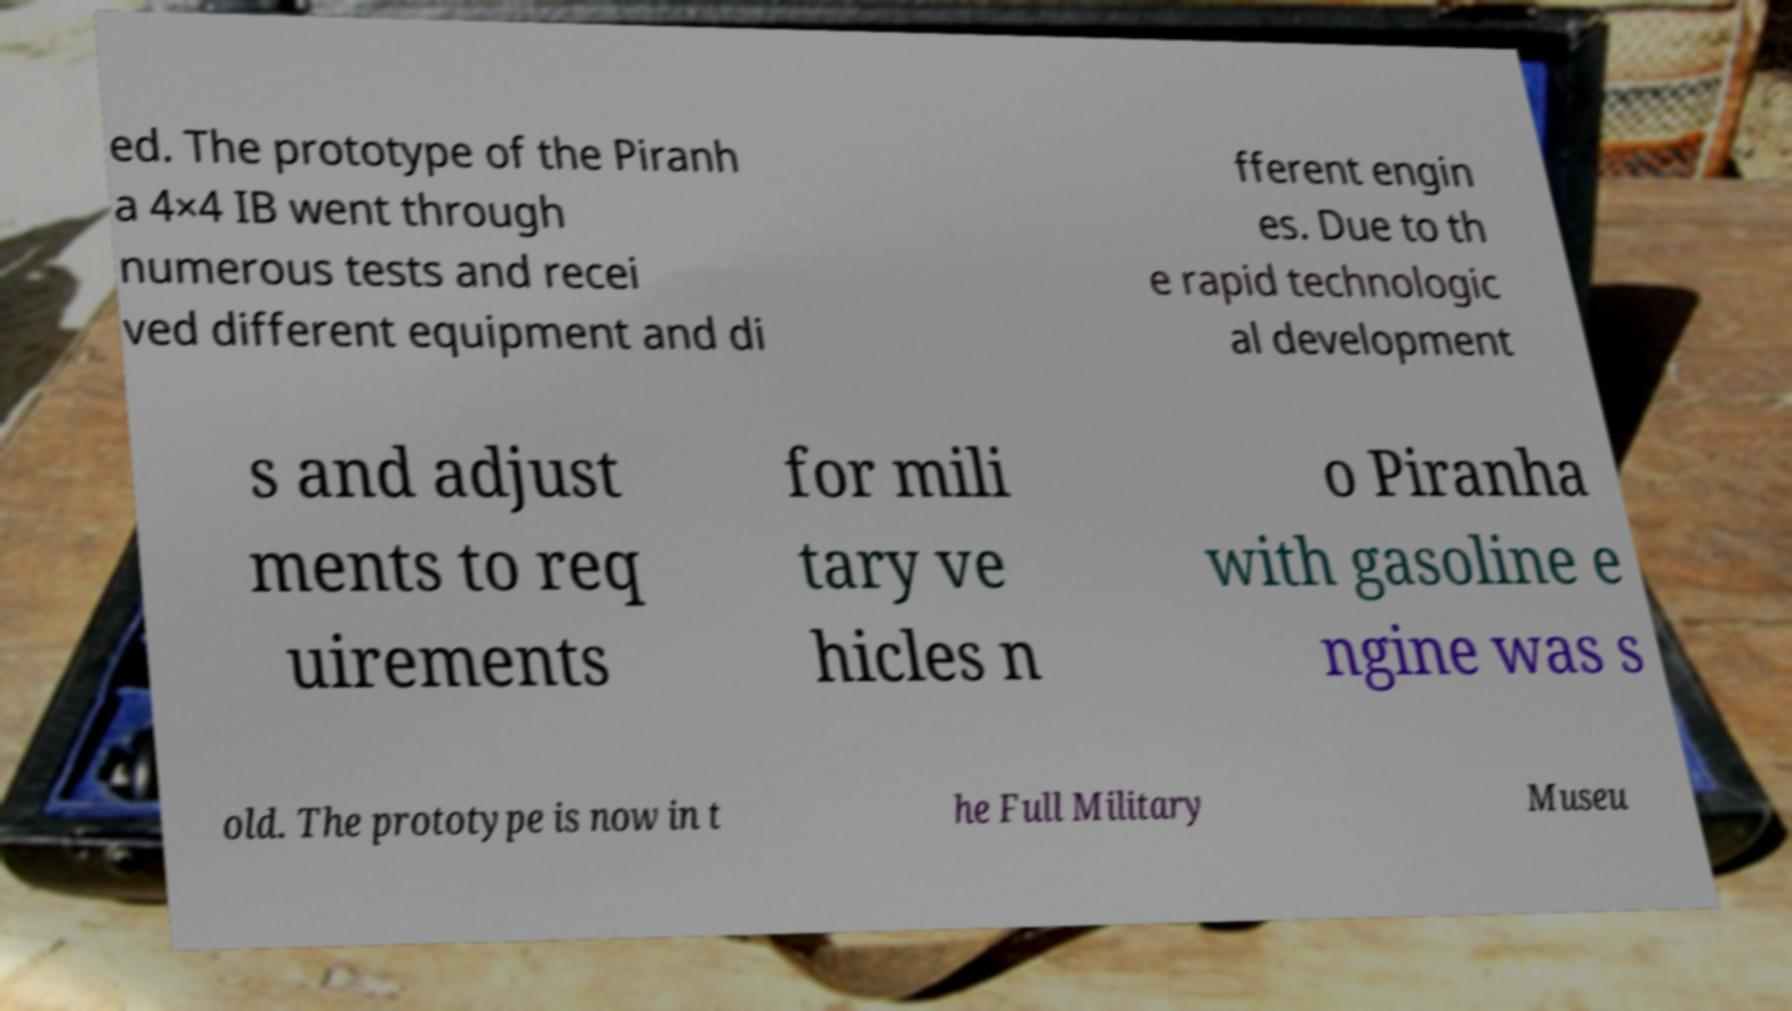There's text embedded in this image that I need extracted. Can you transcribe it verbatim? ed. The prototype of the Piranh a 4×4 IB went through numerous tests and recei ved different equipment and di fferent engin es. Due to th e rapid technologic al development s and adjust ments to req uirements for mili tary ve hicles n o Piranha with gasoline e ngine was s old. The prototype is now in t he Full Military Museu 